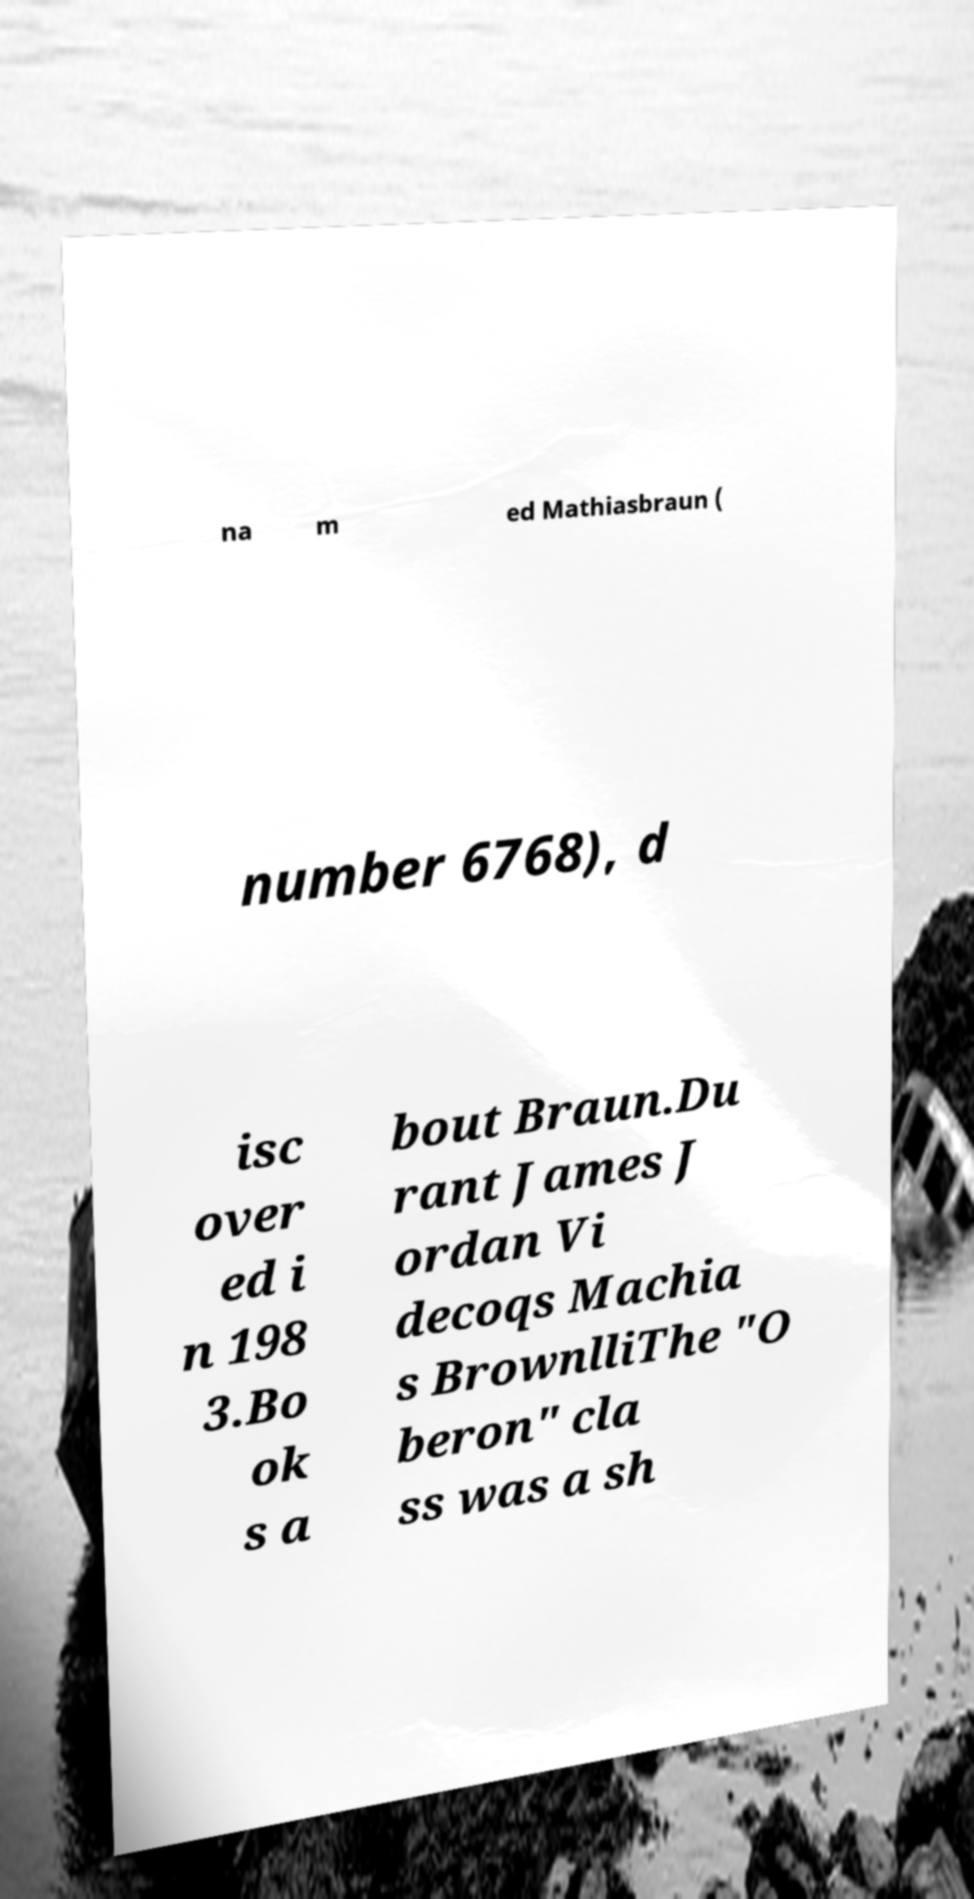Can you accurately transcribe the text from the provided image for me? na m ed Mathiasbraun ( number 6768), d isc over ed i n 198 3.Bo ok s a bout Braun.Du rant James J ordan Vi decoqs Machia s BrownlliThe "O beron" cla ss was a sh 